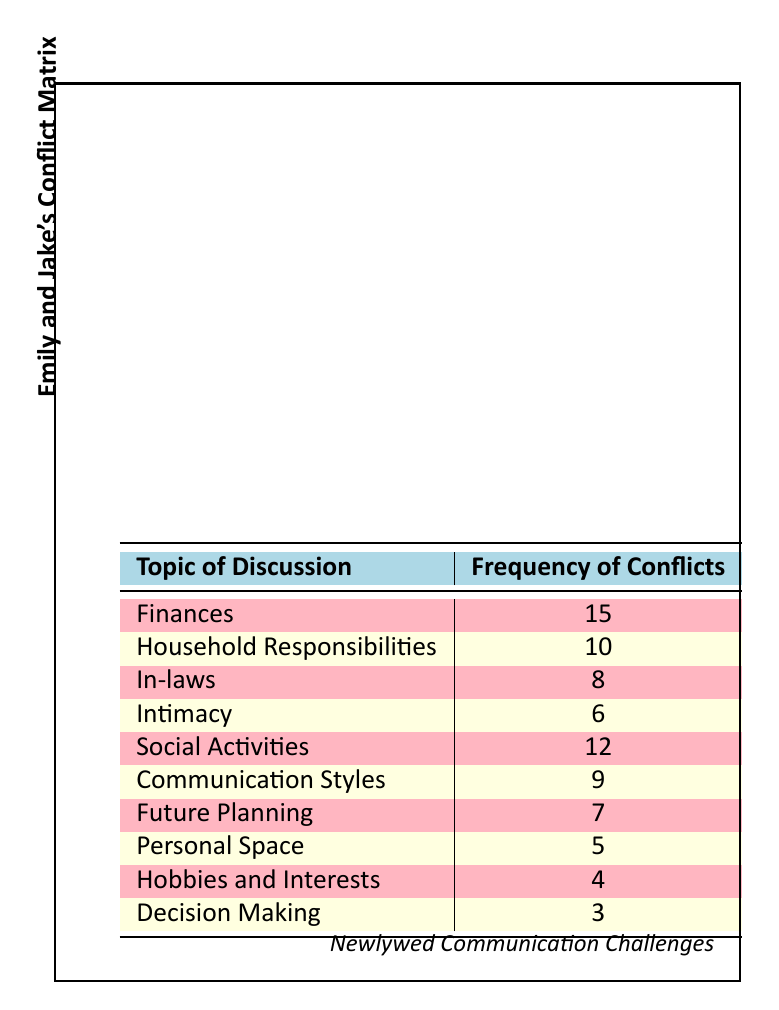What is the most frequent topic of conflict for Emily and Jake? The table shows frequencies for various topics of conflict. Looking through the frequencies, "Finances" has the highest frequency at 15.
Answer: Finances How many topics have a conflict frequency of 10 or more? From the table, the topics with frequency 10 or more are "Finances" (15), "Household Responsibilities" (10), and "Social Activities" (12). This totals to 3 topics.
Answer: 3 Is "Intimacy" one of the top three conflict topics? The frequencies for the topics are ranked, and "Intimacy" has a frequency of 6, which is less than the top three topics – "Finances" (15), "Social Activities" (12), and "Household Responsibilities" (10).
Answer: No What is the total frequency of conflicts related to "In-laws" and "Social Activities"? By locating both topics in the table, "In-laws" has a frequency of 8, while "Social Activities" has a frequency of 12. Adding these together gives 8 + 12 = 20.
Answer: 20 What is the difference in frequency between "Communication Styles" and "Personal Space"? The frequency for "Communication Styles" is 9 and for "Personal Space" is 5. Calculating the difference gives 9 - 5 = 4.
Answer: 4 How many conflict topics have a frequency of less than 5? The table indicates that "Personal Space" has a frequency of 5, and "Hobbies and Interests" has a frequency of 4, which indicates that only "Hobbies and Interests" has a frequency less than 5, less than the threshold.
Answer: 1 What is the average frequency of conflicts for all topics listed? To calculate the average, we first sum the frequencies: 15 + 10 + 8 + 6 + 12 + 9 + 7 + 5 + 4 + 3 = 79. There are 10 topics, so the average is 79/10 = 7.9.
Answer: 7.9 Are there more conflicts about "Future Planning" than "Hobbies and Interests"? "Future Planning" has a frequency of 7 and "Hobbies and Interests" has a frequency of 4. Since 7 is greater than 4, there are indeed more conflicts about "Future Planning."
Answer: Yes 